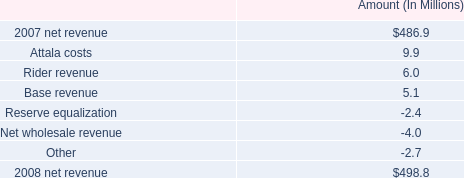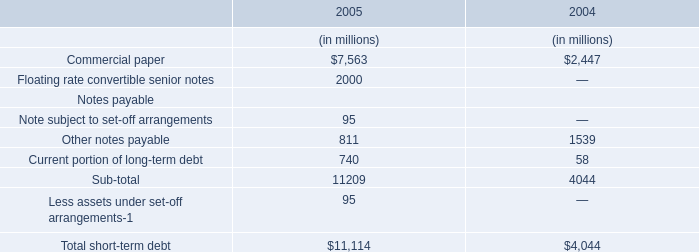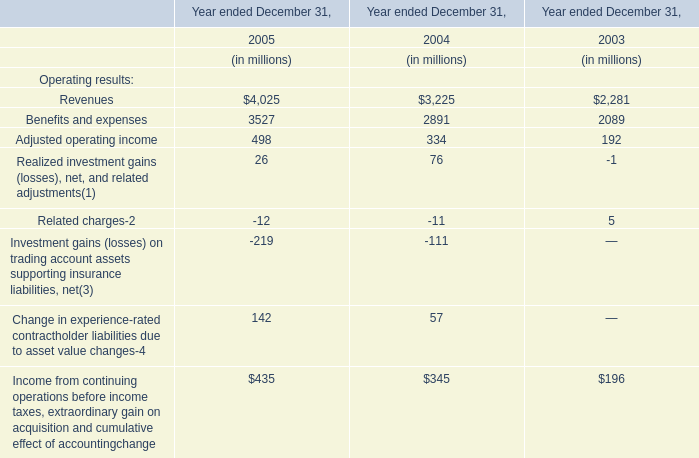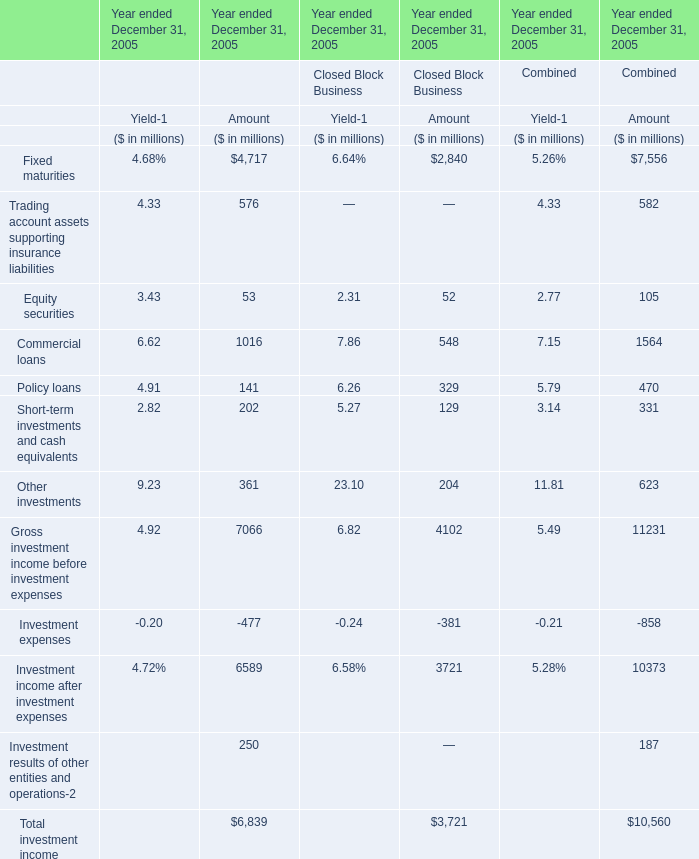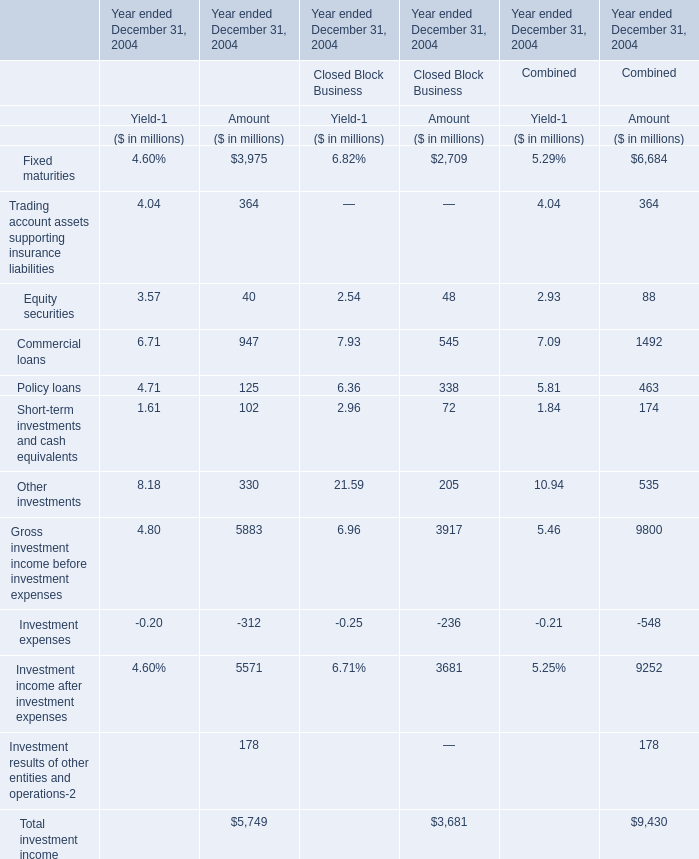What is the difference between the greatest Fixed maturities in Financial Services Businesses and Closed Block Business for amount? 
Computations: (4717 - 2840)
Answer: 1877.0. 